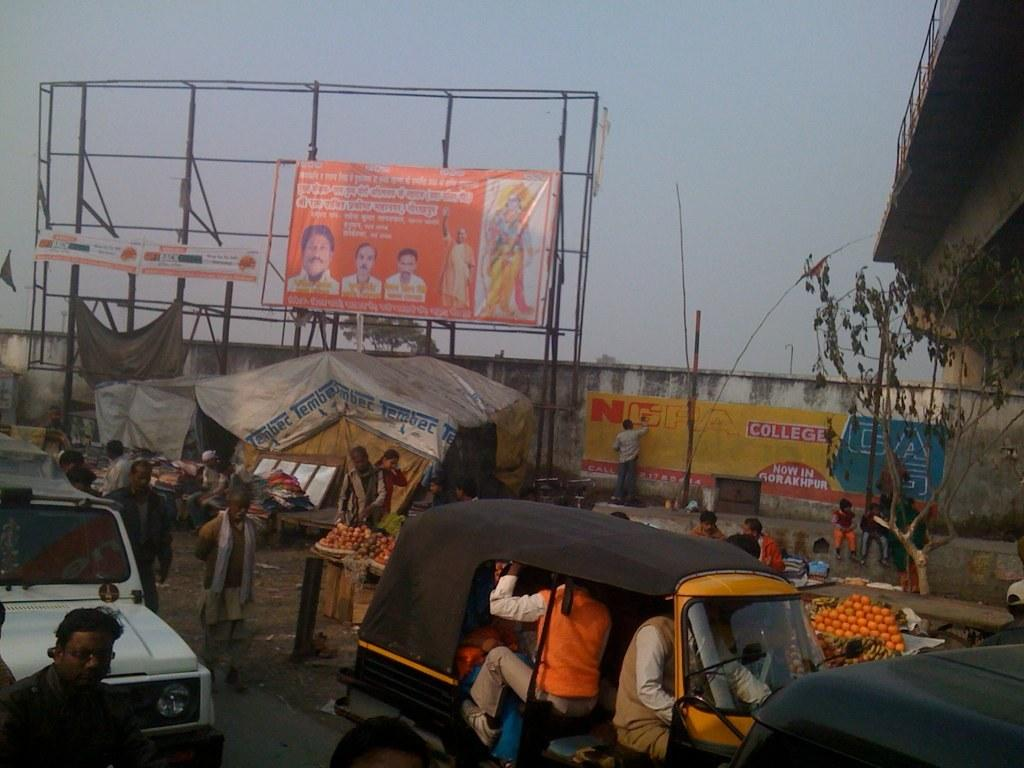<image>
Share a concise interpretation of the image provided. A man is painting in the word NCPA College, on a banner that is hung on a wall, on the side of a street. 